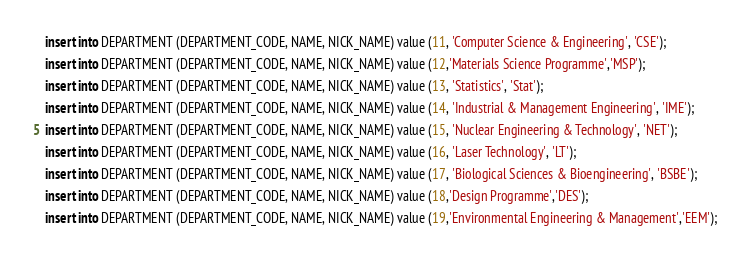Convert code to text. <code><loc_0><loc_0><loc_500><loc_500><_SQL_>insert into DEPARTMENT (DEPARTMENT_CODE, NAME, NICK_NAME) value (11, 'Computer Science & Engineering', 'CSE');
insert into DEPARTMENT (DEPARTMENT_CODE, NAME, NICK_NAME) value (12,'Materials Science Programme','MSP');
insert into DEPARTMENT (DEPARTMENT_CODE, NAME, NICK_NAME) value (13, 'Statistics', 'Stat');
insert into DEPARTMENT (DEPARTMENT_CODE, NAME, NICK_NAME) value (14, 'Industrial & Management Engineering', 'IME');
insert into DEPARTMENT (DEPARTMENT_CODE, NAME, NICK_NAME) value (15, 'Nuclear Engineering & Technology', 'NET');
insert into DEPARTMENT (DEPARTMENT_CODE, NAME, NICK_NAME) value (16, 'Laser Technology', 'LT');
insert into DEPARTMENT (DEPARTMENT_CODE, NAME, NICK_NAME) value (17, 'Biological Sciences & Bioengineering', 'BSBE');
insert into DEPARTMENT (DEPARTMENT_CODE, NAME, NICK_NAME) value (18,'Design Programme','DES');
insert into DEPARTMENT (DEPARTMENT_CODE, NAME, NICK_NAME) value (19,'Environmental Engineering & Management','EEM');

</code> 